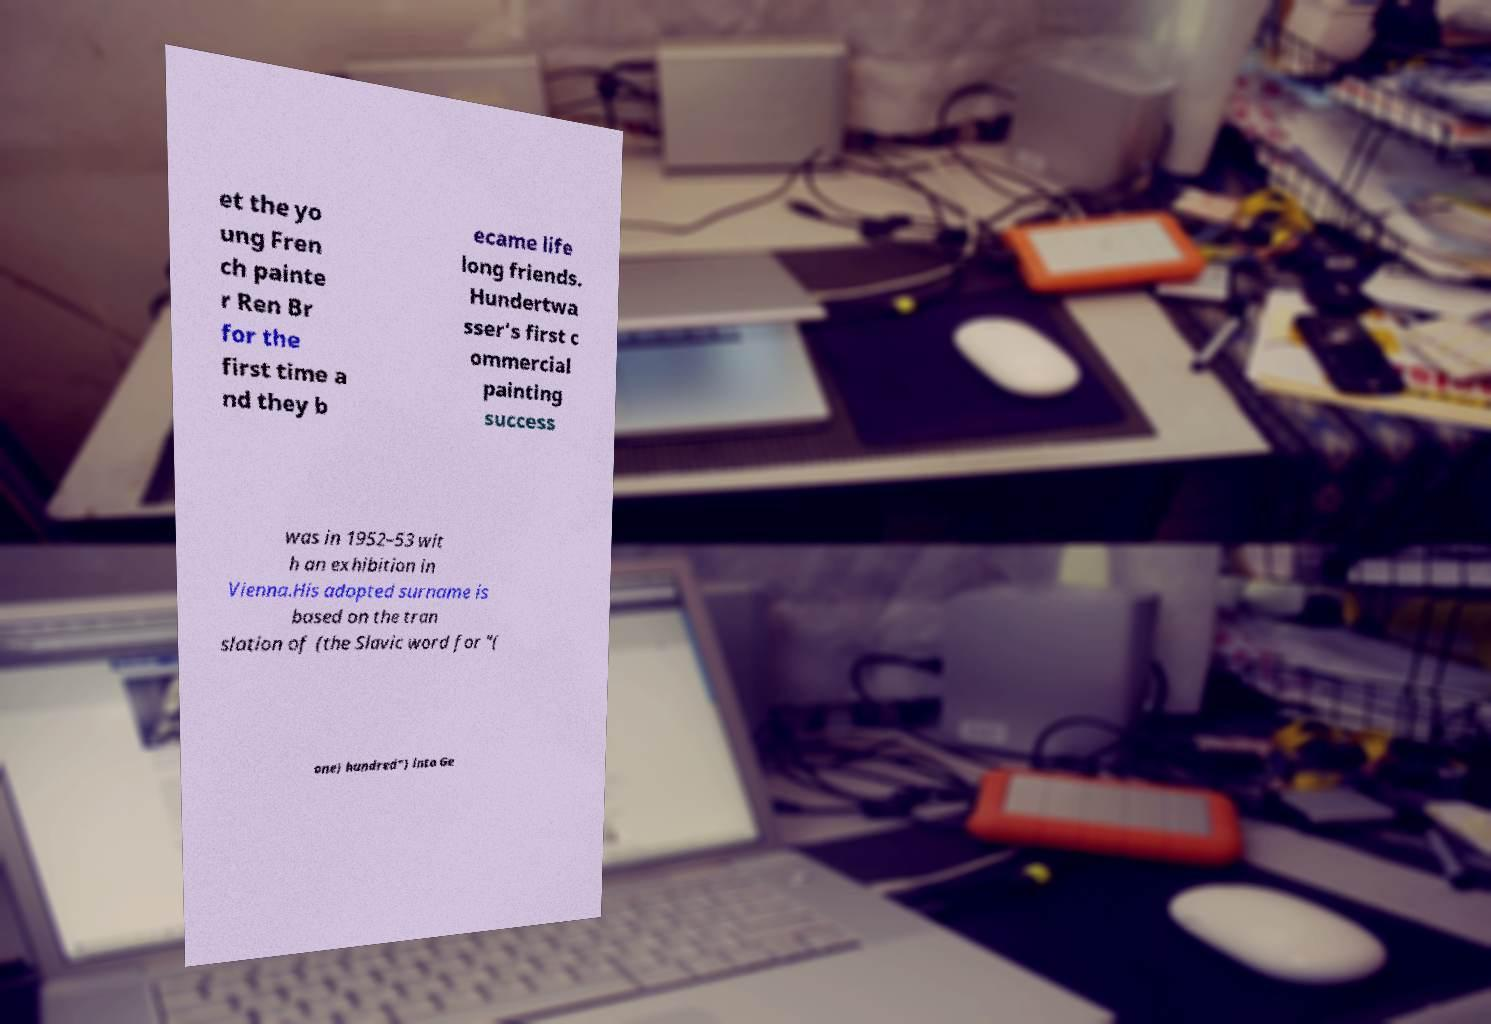Please identify and transcribe the text found in this image. et the yo ung Fren ch painte r Ren Br for the first time a nd they b ecame life long friends. Hundertwa sser's first c ommercial painting success was in 1952–53 wit h an exhibition in Vienna.His adopted surname is based on the tran slation of (the Slavic word for "( one) hundred") into Ge 